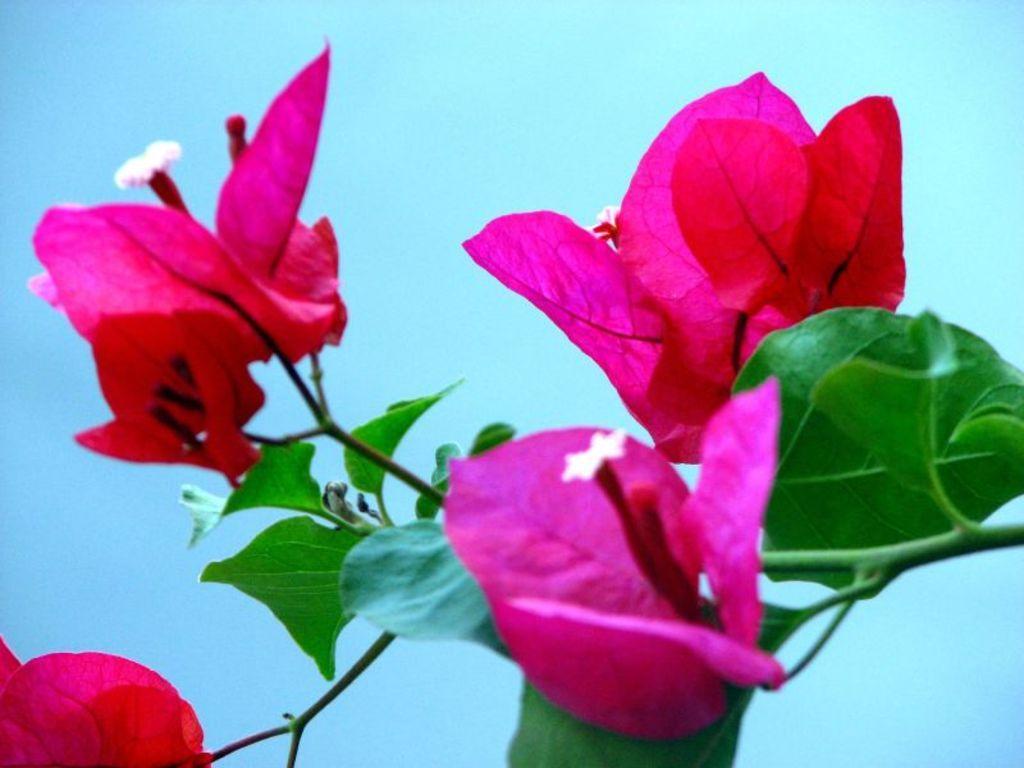Describe this image in one or two sentences. In this image there are pink flowers in the middle. On the right side there are green leaves. 